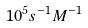<formula> <loc_0><loc_0><loc_500><loc_500>1 0 ^ { 5 } { s } ^ { - 1 } { M } ^ { - 1 }</formula> 